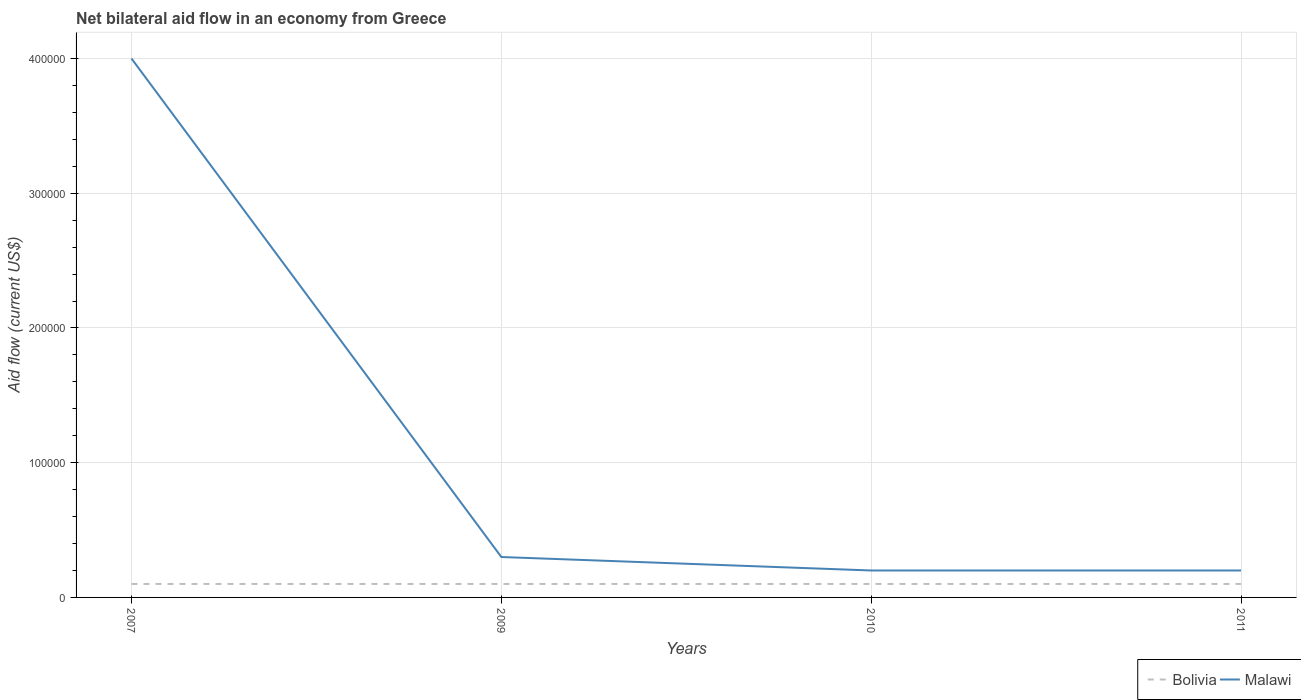How many different coloured lines are there?
Give a very brief answer. 2. Does the line corresponding to Bolivia intersect with the line corresponding to Malawi?
Your response must be concise. No. Is the number of lines equal to the number of legend labels?
Your answer should be very brief. Yes. Across all years, what is the maximum net bilateral aid flow in Bolivia?
Offer a terse response. 10000. In which year was the net bilateral aid flow in Bolivia maximum?
Make the answer very short. 2007. What is the total net bilateral aid flow in Bolivia in the graph?
Offer a terse response. 0. What is the difference between the highest and the second highest net bilateral aid flow in Malawi?
Provide a succinct answer. 3.80e+05. What is the difference between the highest and the lowest net bilateral aid flow in Malawi?
Provide a succinct answer. 1. How many years are there in the graph?
Offer a terse response. 4. Are the values on the major ticks of Y-axis written in scientific E-notation?
Offer a very short reply. No. Does the graph contain grids?
Offer a terse response. Yes. What is the title of the graph?
Provide a short and direct response. Net bilateral aid flow in an economy from Greece. Does "Serbia" appear as one of the legend labels in the graph?
Provide a succinct answer. No. What is the Aid flow (current US$) in Malawi in 2007?
Keep it short and to the point. 4.00e+05. What is the Aid flow (current US$) of Malawi in 2009?
Offer a very short reply. 3.00e+04. What is the Aid flow (current US$) in Bolivia in 2011?
Offer a terse response. 10000. What is the Aid flow (current US$) in Malawi in 2011?
Ensure brevity in your answer.  2.00e+04. Across all years, what is the maximum Aid flow (current US$) of Bolivia?
Give a very brief answer. 10000. Across all years, what is the minimum Aid flow (current US$) of Bolivia?
Offer a very short reply. 10000. Across all years, what is the minimum Aid flow (current US$) in Malawi?
Give a very brief answer. 2.00e+04. What is the total Aid flow (current US$) in Malawi in the graph?
Keep it short and to the point. 4.70e+05. What is the difference between the Aid flow (current US$) of Malawi in 2007 and that in 2009?
Provide a short and direct response. 3.70e+05. What is the difference between the Aid flow (current US$) of Bolivia in 2007 and that in 2011?
Provide a short and direct response. 0. What is the difference between the Aid flow (current US$) in Bolivia in 2009 and that in 2010?
Offer a terse response. 0. What is the difference between the Aid flow (current US$) of Bolivia in 2009 and that in 2011?
Ensure brevity in your answer.  0. What is the difference between the Aid flow (current US$) of Malawi in 2009 and that in 2011?
Give a very brief answer. 10000. What is the difference between the Aid flow (current US$) of Bolivia in 2007 and the Aid flow (current US$) of Malawi in 2009?
Your answer should be compact. -2.00e+04. What is the difference between the Aid flow (current US$) of Bolivia in 2007 and the Aid flow (current US$) of Malawi in 2010?
Ensure brevity in your answer.  -10000. What is the difference between the Aid flow (current US$) of Bolivia in 2007 and the Aid flow (current US$) of Malawi in 2011?
Provide a succinct answer. -10000. What is the difference between the Aid flow (current US$) of Bolivia in 2009 and the Aid flow (current US$) of Malawi in 2010?
Provide a succinct answer. -10000. What is the average Aid flow (current US$) in Bolivia per year?
Ensure brevity in your answer.  10000. What is the average Aid flow (current US$) in Malawi per year?
Provide a succinct answer. 1.18e+05. In the year 2007, what is the difference between the Aid flow (current US$) in Bolivia and Aid flow (current US$) in Malawi?
Give a very brief answer. -3.90e+05. In the year 2011, what is the difference between the Aid flow (current US$) of Bolivia and Aid flow (current US$) of Malawi?
Offer a very short reply. -10000. What is the ratio of the Aid flow (current US$) of Bolivia in 2007 to that in 2009?
Your answer should be very brief. 1. What is the ratio of the Aid flow (current US$) of Malawi in 2007 to that in 2009?
Provide a succinct answer. 13.33. What is the ratio of the Aid flow (current US$) of Malawi in 2007 to that in 2010?
Your answer should be compact. 20. What is the ratio of the Aid flow (current US$) in Bolivia in 2007 to that in 2011?
Make the answer very short. 1. What is the ratio of the Aid flow (current US$) of Bolivia in 2009 to that in 2010?
Your answer should be compact. 1. What is the ratio of the Aid flow (current US$) of Malawi in 2009 to that in 2010?
Your answer should be very brief. 1.5. What is the ratio of the Aid flow (current US$) in Bolivia in 2009 to that in 2011?
Offer a terse response. 1. What is the ratio of the Aid flow (current US$) of Malawi in 2010 to that in 2011?
Offer a very short reply. 1. What is the difference between the highest and the second highest Aid flow (current US$) in Bolivia?
Make the answer very short. 0. What is the difference between the highest and the second highest Aid flow (current US$) in Malawi?
Provide a short and direct response. 3.70e+05. 